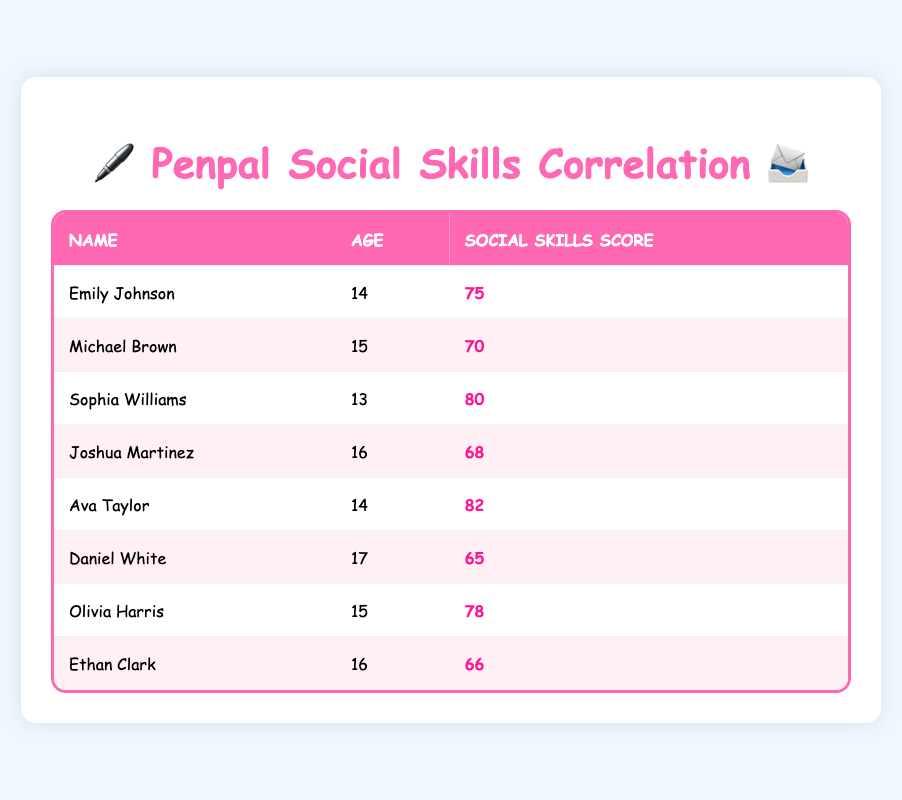What is the social skills score of Ava Taylor? The social skills score of Ava Taylor is displayed in her corresponding row. Looking under the "Social Skills Score" column for Ava Taylor, it shows a value of 82.
Answer: 82 Which penpal is the youngest? To find the youngest penpal, we compare the ages listed. Sophia Williams is 13 years old, which is lower than the ages of all the other penpals.
Answer: Sophia Williams What is the average social skills score of the penpals aged 15? We look at the penpals who are 15, which are Michael Brown and Olivia Harris. Their scores are 70 and 78. To find the average, we add these scores (70 + 78 = 148) and divide by 2, resulting in 148/2 = 74.
Answer: 74 Is there a penpal with a score higher than 80? To answer this, we check all scores in the "Social Skills Score" column. Only Sophia Williams (80) and Ava Taylor (82) have scores greater than 80. Since Ava has a score of 82, the answer is yes.
Answer: Yes What is the difference between the highest and lowest social skills scores among the penpals? First, we identify the highest score, which is 82 (Ava Taylor), and the lowest score, which is 65 (Daniel White). The difference is calculated by subtracting the lowest score from the highest score: 82 - 65 = 17.
Answer: 17 How many penpals are aged 16? Looking under the "Age" column, we find the penpals who are 16: Joshua Martinez and Ethan Clark. There are 2 penpals in this category.
Answer: 2 Which penpal has a score of 68? We check the "Social Skills Score" column for the score of 68. Looking through the rows, we see that Joshua Martinez has a score of 68.
Answer: Joshua Martinez What is the median age of the penpals? To find the median age, we first list the ages of all penpals: 13, 14, 14, 15, 15, 16, 16, 17. Since there are 8 values (an even number), we take the average of the two middle numbers (15 and 15), resulting in a median age of 15.
Answer: 15 